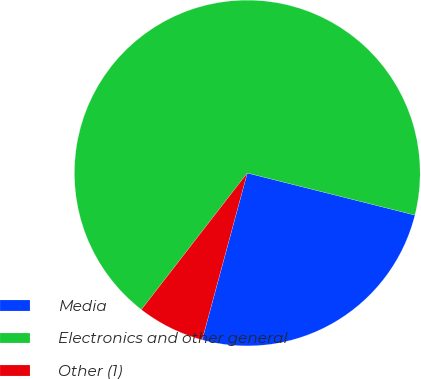Convert chart. <chart><loc_0><loc_0><loc_500><loc_500><pie_chart><fcel>Media<fcel>Electronics and other general<fcel>Other (1)<nl><fcel>25.29%<fcel>68.42%<fcel>6.29%<nl></chart> 